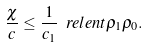Convert formula to latex. <formula><loc_0><loc_0><loc_500><loc_500>\frac { \chi } { c } \leq \frac { 1 } { c _ { 1 } } \ r e l e n t { \rho _ { 1 } } { \rho _ { 0 } } .</formula> 